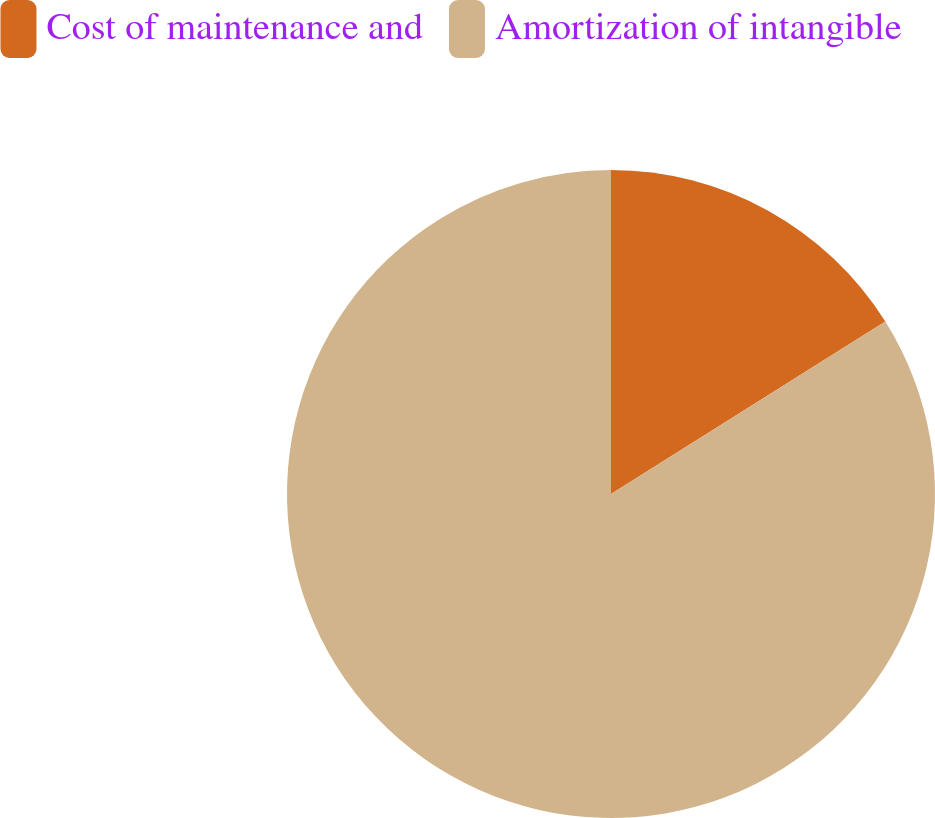<chart> <loc_0><loc_0><loc_500><loc_500><pie_chart><fcel>Cost of maintenance and<fcel>Amortization of intangible<nl><fcel>16.07%<fcel>83.93%<nl></chart> 